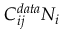Convert formula to latex. <formula><loc_0><loc_0><loc_500><loc_500>C _ { i j } ^ { d a t a } N _ { i }</formula> 